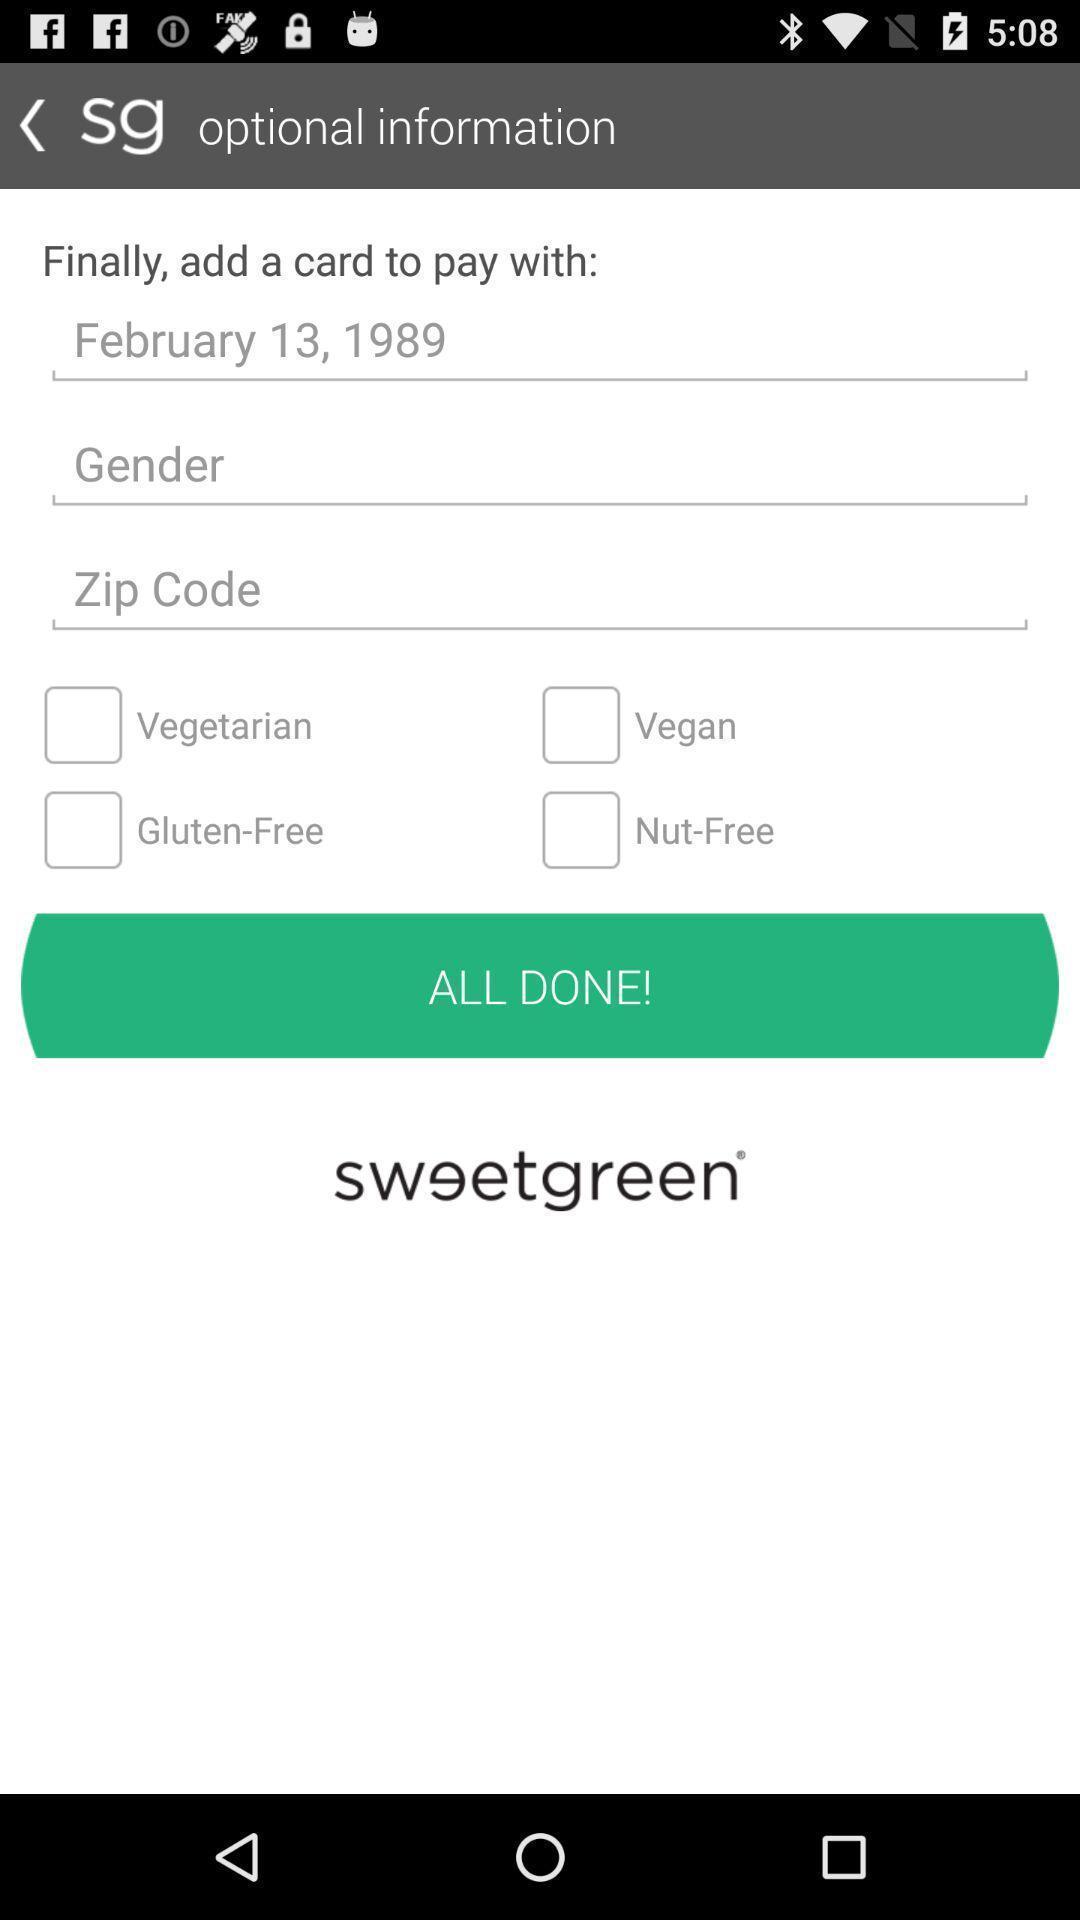What can you discern from this picture? Screen displaying optional information. 